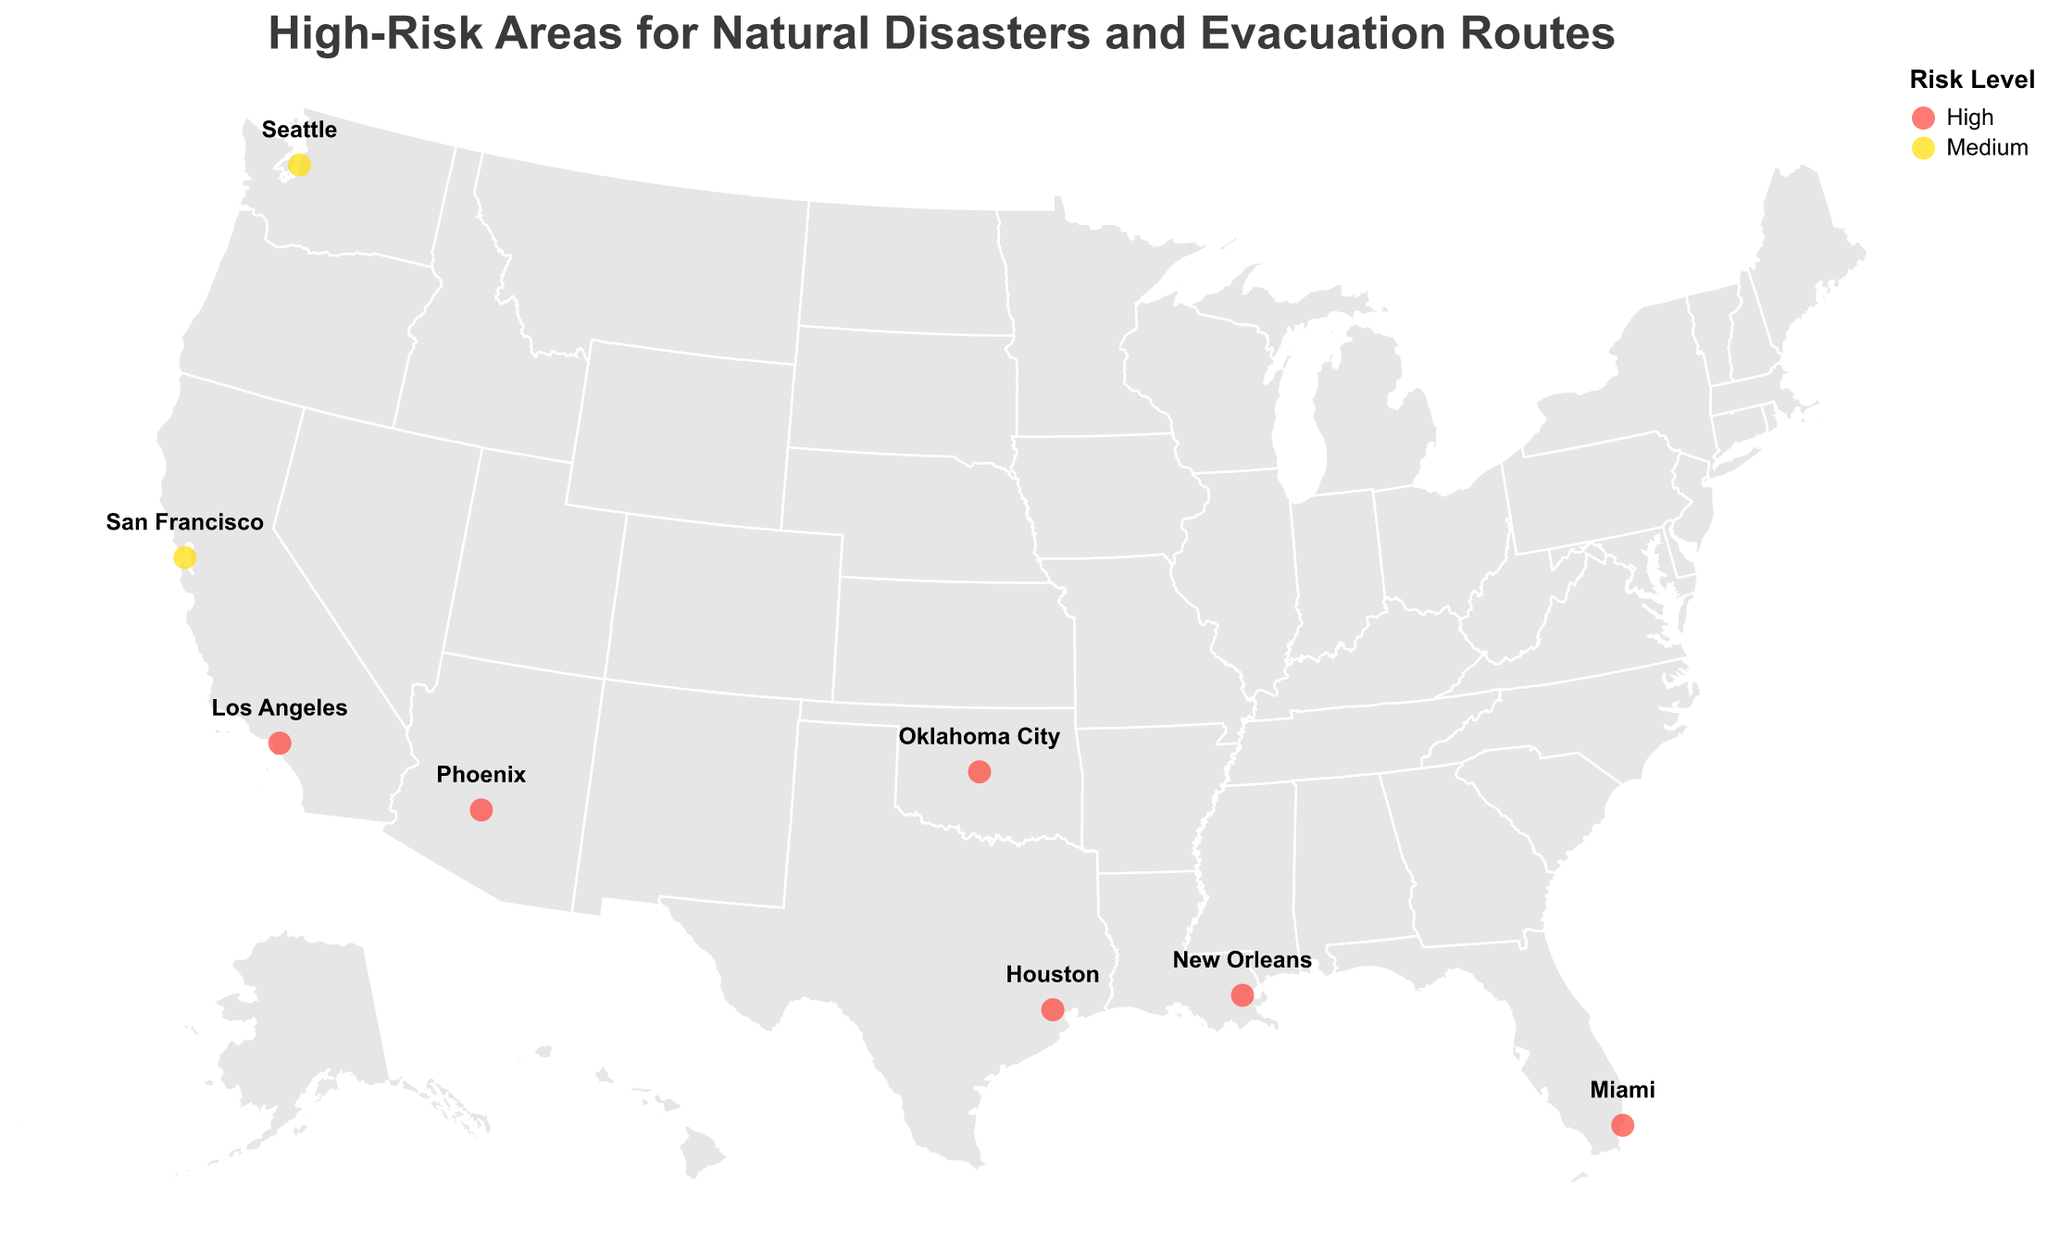What is the title of the figure? The title is prominent and located at the top of the figure. It states the main topic of the visual representation.
Answer: High-Risk Areas for Natural Disasters and Evacuation Routes How many high-risk location points are marked on the map? Count the number of circles colored in red, representing high-risk locations. There are multiple points denoted by these circles.
Answer: 8 Which type of natural disaster is most frequently occurring in the high-risk locations? Review the tooltip information of each high-risk location (colored red) and count the occurrence frequency of each disaster type (Earthquake, Hurricane, Flood, etc.).
Answer: Tornado and Flood What colors are used to represent the risk levels, and what do they signify? Identify the colors of the circles and refer to the legend to determine what each color represents.
Answer: Red for High Risk, Yellow for Medium Risk Which high-risk location has the northernmost latitude? Compare the latitude values of all high-risk locations and identify the one with the highest numerical value.
Answer: Anchorage Which locations are marked with a medium risk level? Identify and list all locations that are associated with yellow circles on the map.
Answer: San Francisco, Seattle, Honolulu, Anchorage What evacuation route serves Miami? Hover over the circle marking Miami to display the tooltip with detailed information, including the evacuation route.
Answer: Florida Turnpike North How many types of natural disasters are represented in the figure? Count the unique types of natural disasters associated with all marked locations.
Answer: 9 Compare the risk levels of Houston and Phoenix. Which one has a higher risk level? Check the color-coded circles for Houston and Phoenix, referring to the legend if needed.
Answer: Both have a High risk level For locations with high-risk levels, which one has the easternmost longitude? Review the longitude values for all high-risk locations and find the one with the least negative value, indicating the easternmost point.
Answer: Miami 